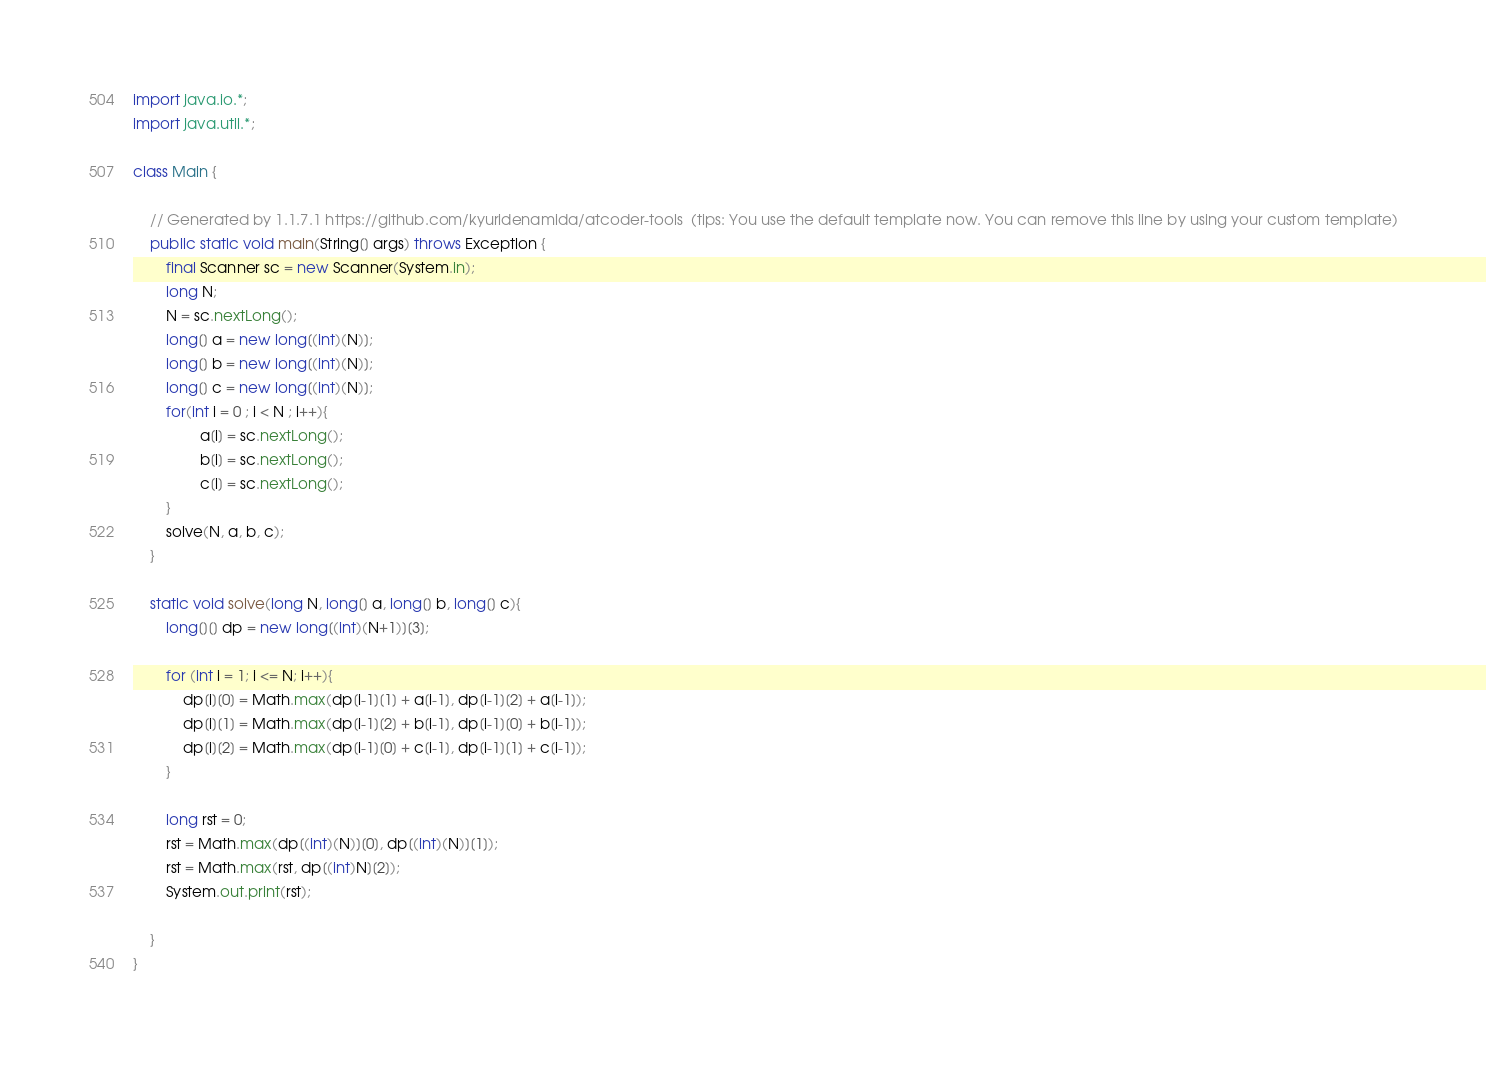<code> <loc_0><loc_0><loc_500><loc_500><_Java_>import java.io.*;
import java.util.*;

class Main {

    // Generated by 1.1.7.1 https://github.com/kyuridenamida/atcoder-tools  (tips: You use the default template now. You can remove this line by using your custom template)
    public static void main(String[] args) throws Exception {
        final Scanner sc = new Scanner(System.in);
        long N;
        N = sc.nextLong();
        long[] a = new long[(int)(N)];
        long[] b = new long[(int)(N)];
        long[] c = new long[(int)(N)];
        for(int i = 0 ; i < N ; i++){
                a[i] = sc.nextLong();
                b[i] = sc.nextLong();
                c[i] = sc.nextLong();
        }
        solve(N, a, b, c);
    }

    static void solve(long N, long[] a, long[] b, long[] c){
        long[][] dp = new long[(int)(N+1)][3];

        for (int i = 1; i <= N; i++){
            dp[i][0] = Math.max(dp[i-1][1] + a[i-1], dp[i-1][2] + a[i-1]);
            dp[i][1] = Math.max(dp[i-1][2] + b[i-1], dp[i-1][0] + b[i-1]);
            dp[i][2] = Math.max(dp[i-1][0] + c[i-1], dp[i-1][1] + c[i-1]);
        }

        long rst = 0;
        rst = Math.max(dp[(int)(N)][0], dp[(int)(N)][1]);
        rst = Math.max(rst, dp[(int)N][2]);
        System.out.print(rst);
        
    }
}
</code> 